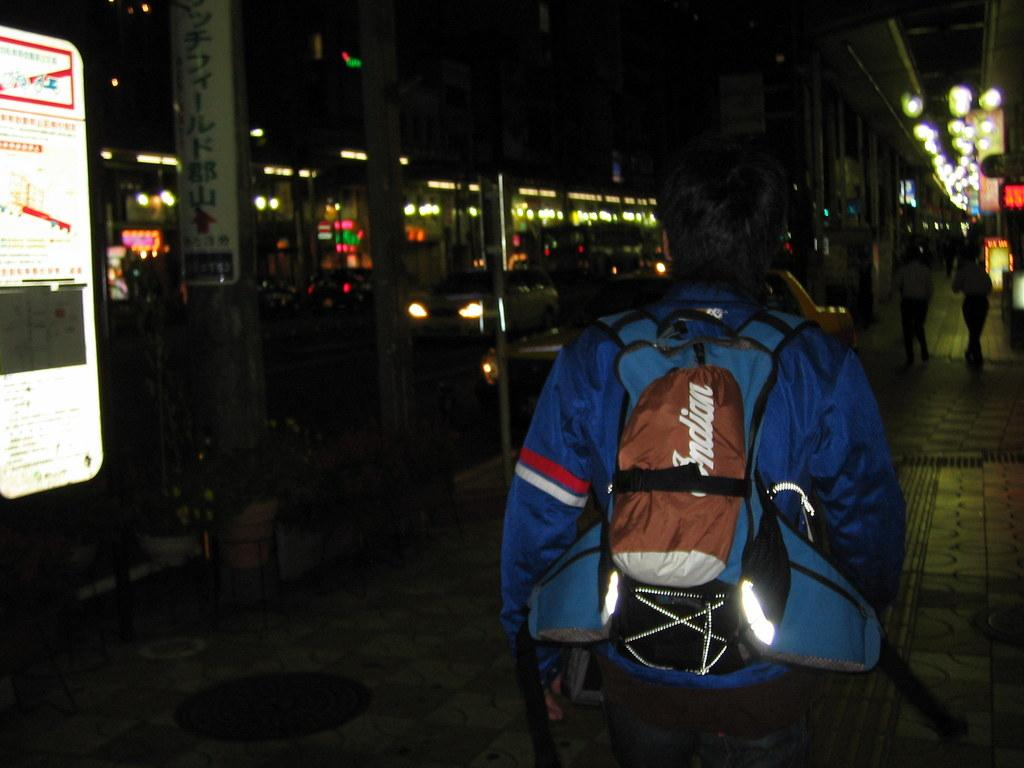What is the person in the image wearing? The person is wearing a bag in the image. Where is the person located in the image? The person is on the road in the image. What can be seen in the background of the image? There are people in the background of the image. What is on the left side of the image? There is a white board on the left side of the image. What is written on the white board? Something is written on the white board, but the specific content is not mentioned in the facts. How many dinosaurs can be seen in the image? There are no dinosaurs present in the image. What type of bun is the person holding in the image? There is no bun visible in the image. 